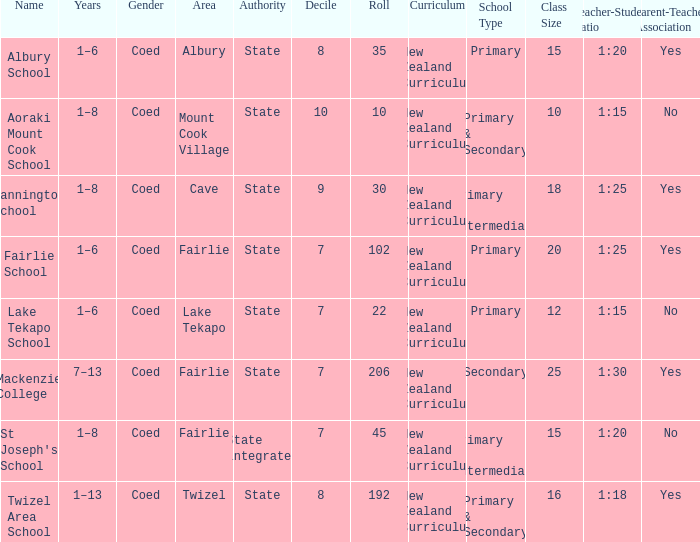What is the total Decile that has a state authority, fairlie area and roll smarter than 206? 1.0. 